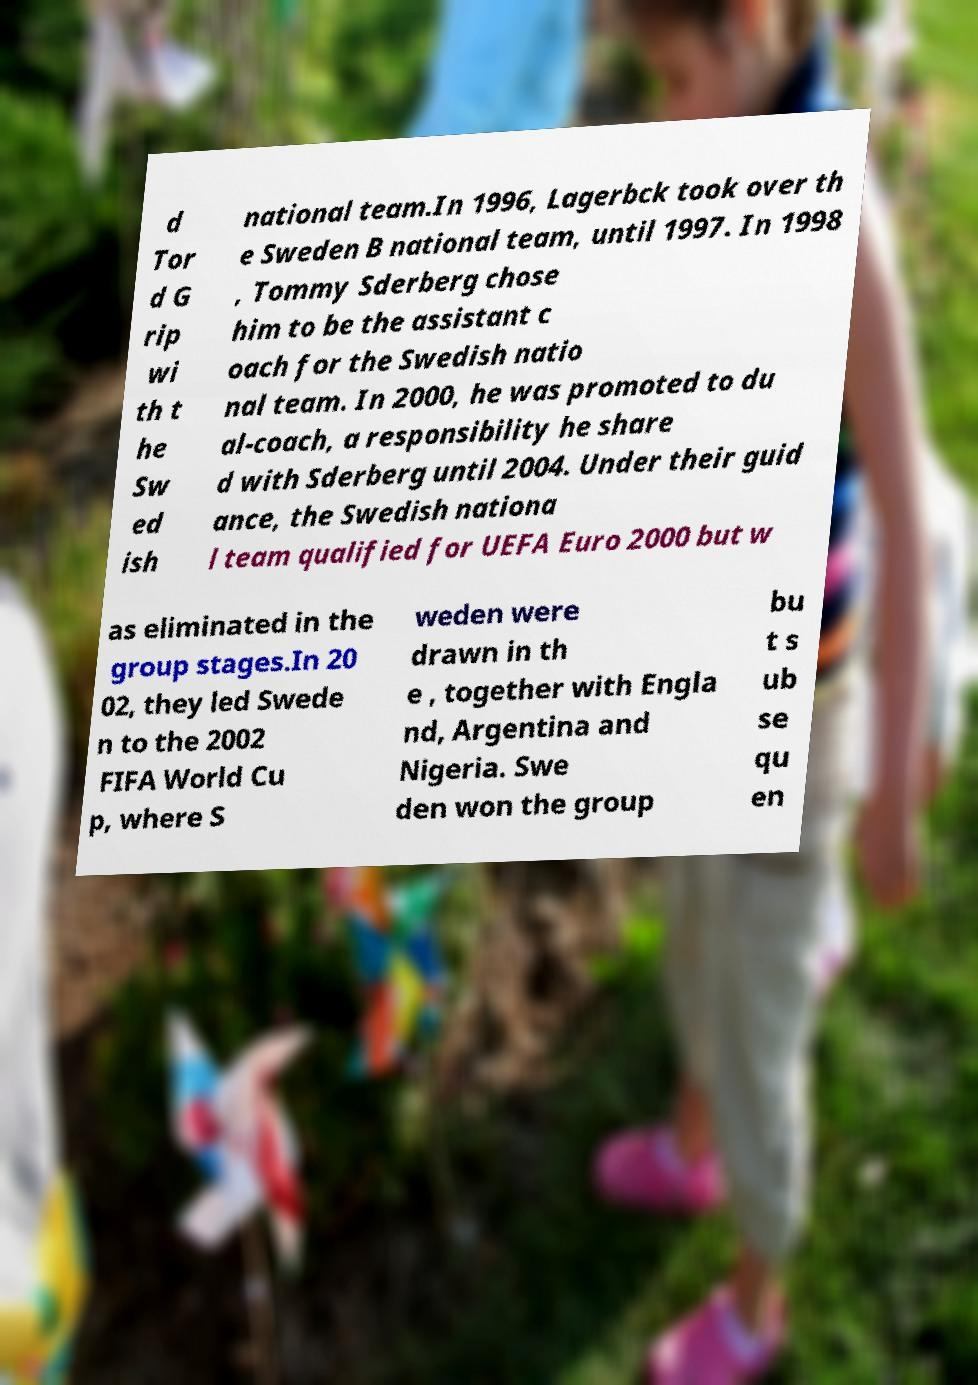For documentation purposes, I need the text within this image transcribed. Could you provide that? d Tor d G rip wi th t he Sw ed ish national team.In 1996, Lagerbck took over th e Sweden B national team, until 1997. In 1998 , Tommy Sderberg chose him to be the assistant c oach for the Swedish natio nal team. In 2000, he was promoted to du al-coach, a responsibility he share d with Sderberg until 2004. Under their guid ance, the Swedish nationa l team qualified for UEFA Euro 2000 but w as eliminated in the group stages.In 20 02, they led Swede n to the 2002 FIFA World Cu p, where S weden were drawn in th e , together with Engla nd, Argentina and Nigeria. Swe den won the group bu t s ub se qu en 